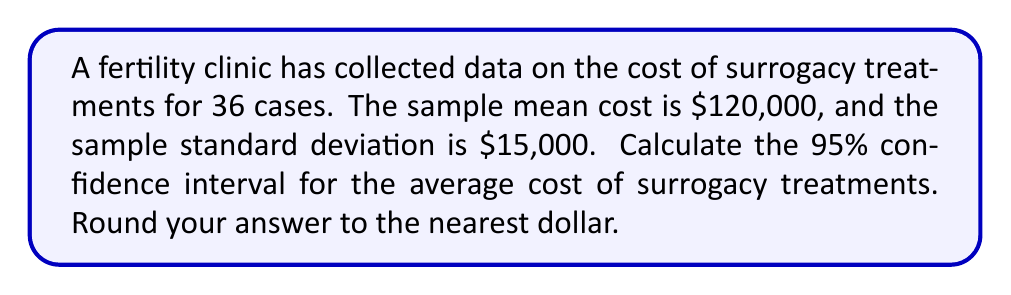Can you answer this question? To calculate the confidence interval, we'll follow these steps:

1. Identify the given information:
   - Sample size: $n = 36$
   - Sample mean: $\bar{x} = \$120,000$
   - Sample standard deviation: $s = \$15,000$
   - Confidence level: 95%

2. Determine the critical value:
   For a 95% confidence level with df = 35, the t-value is approximately 2.030.

3. Calculate the standard error of the mean:
   $SE = \frac{s}{\sqrt{n}} = \frac{\$15,000}{\sqrt{36}} = \$2,500$

4. Calculate the margin of error:
   $ME = t \times SE = 2.030 \times \$2,500 = \$5,075$

5. Compute the confidence interval:
   Lower bound: $\bar{x} - ME = \$120,000 - \$5,075 = \$114,925$
   Upper bound: $\bar{x} + ME = \$120,000 + \$5,075 = \$125,075$

Therefore, the 95% confidence interval for the average cost of surrogacy treatments is (\$114,925, \$125,075).
Answer: (\$114,925, \$125,075) 